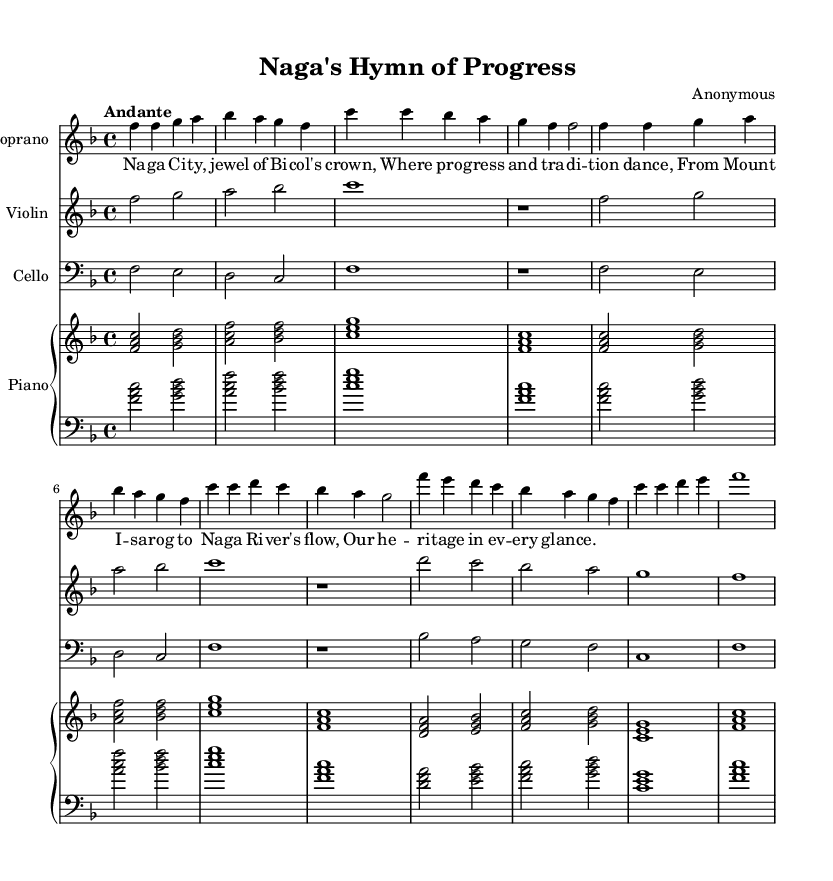What is the key signature of this music? The key signature is F major, which has one flat (B flat). This can be identified by looking at the key signature shown at the beginning of the staff in the sheet music.
Answer: F major What is the time signature of this music? The time signature is 4/4, which indicates that there are four beats in each measure and the quarter note gets one beat. This is visible at the beginning of the score next to the key signature.
Answer: 4/4 What is the tempo marking for this piece? The tempo marking is "Andante", indicating a moderate tempo. This is specified at the beginning of the score just before the music starts.
Answer: Andante How many measures are in the soprano voice section? There are 8 measures in the soprano voice section. Counting each group of notes divided by vertical lines in the soprano staff will give the total number of measures.
Answer: 8 What is the role of the piano in this opera piece? The piano serves as an accompaniment, providing harmonic support and structure throughout the piece. It can be seen in the score providing chords that complement the vocal lines and instruments.
Answer: Accompaniment What is the text of the first line of the soprano lyrics? The first line of the soprano lyrics is "Naga City, jewel of Bicol's crown," which is indicated below the notes in the soprano voice section.
Answer: Naga City, jewel of Bicol's crown How does the use of instruments enhance the opera's theme? The instruments such as violin and cello provide depth and emotional expression, complementing the vocal lines. They help to create an atmosphere that reflects the cultural and historical significance of Naga City portrayed in the lyrics.
Answer: Depth and emotional expression 